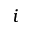Convert formula to latex. <formula><loc_0><loc_0><loc_500><loc_500>i</formula> 